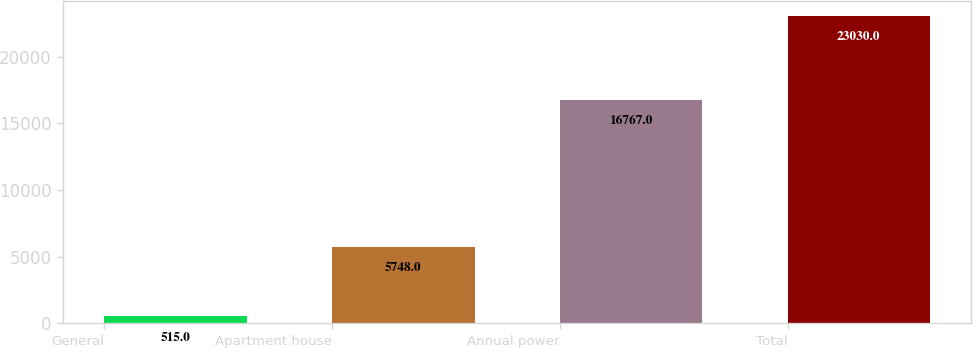Convert chart to OTSL. <chart><loc_0><loc_0><loc_500><loc_500><bar_chart><fcel>General<fcel>Apartment house<fcel>Annual power<fcel>Total<nl><fcel>515<fcel>5748<fcel>16767<fcel>23030<nl></chart> 